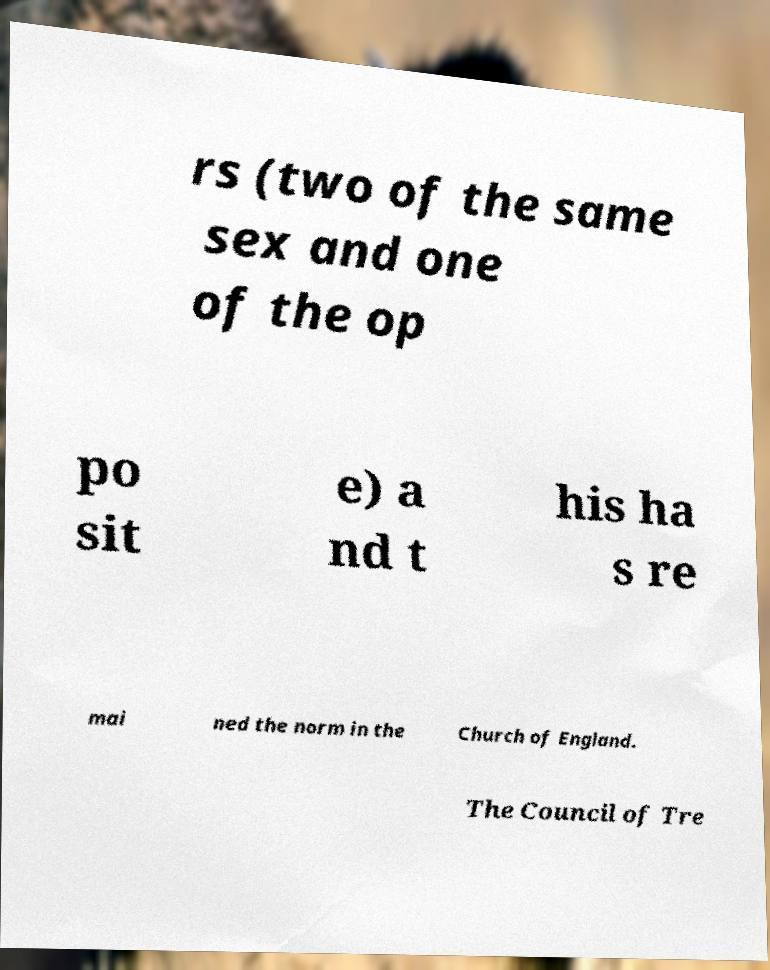There's text embedded in this image that I need extracted. Can you transcribe it verbatim? rs (two of the same sex and one of the op po sit e) a nd t his ha s re mai ned the norm in the Church of England. The Council of Tre 